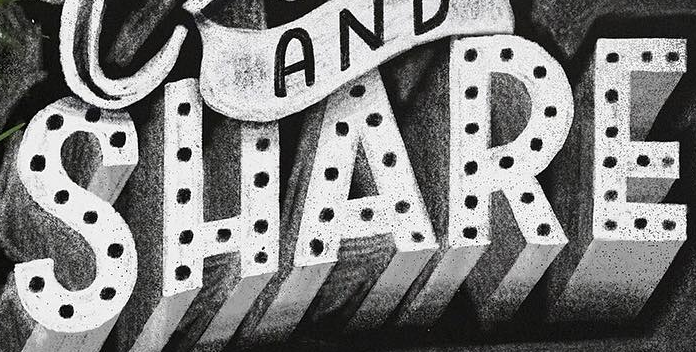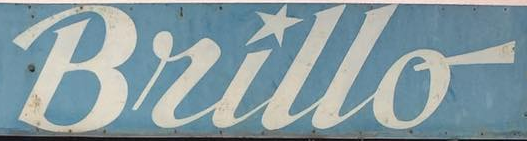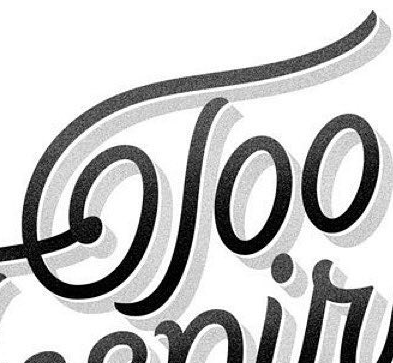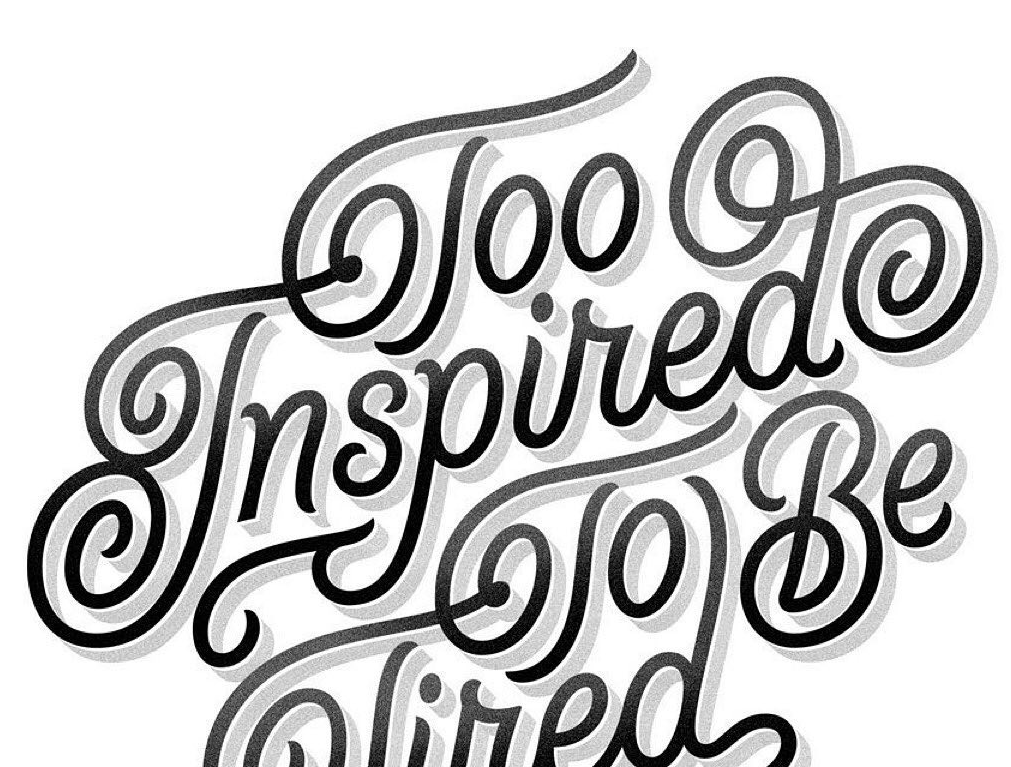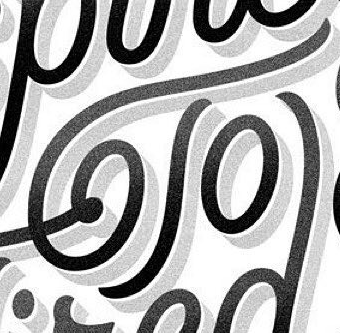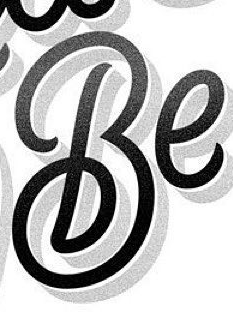Read the text from these images in sequence, separated by a semicolon. SHARE; Bullo; Too; Inspired; To; Be 